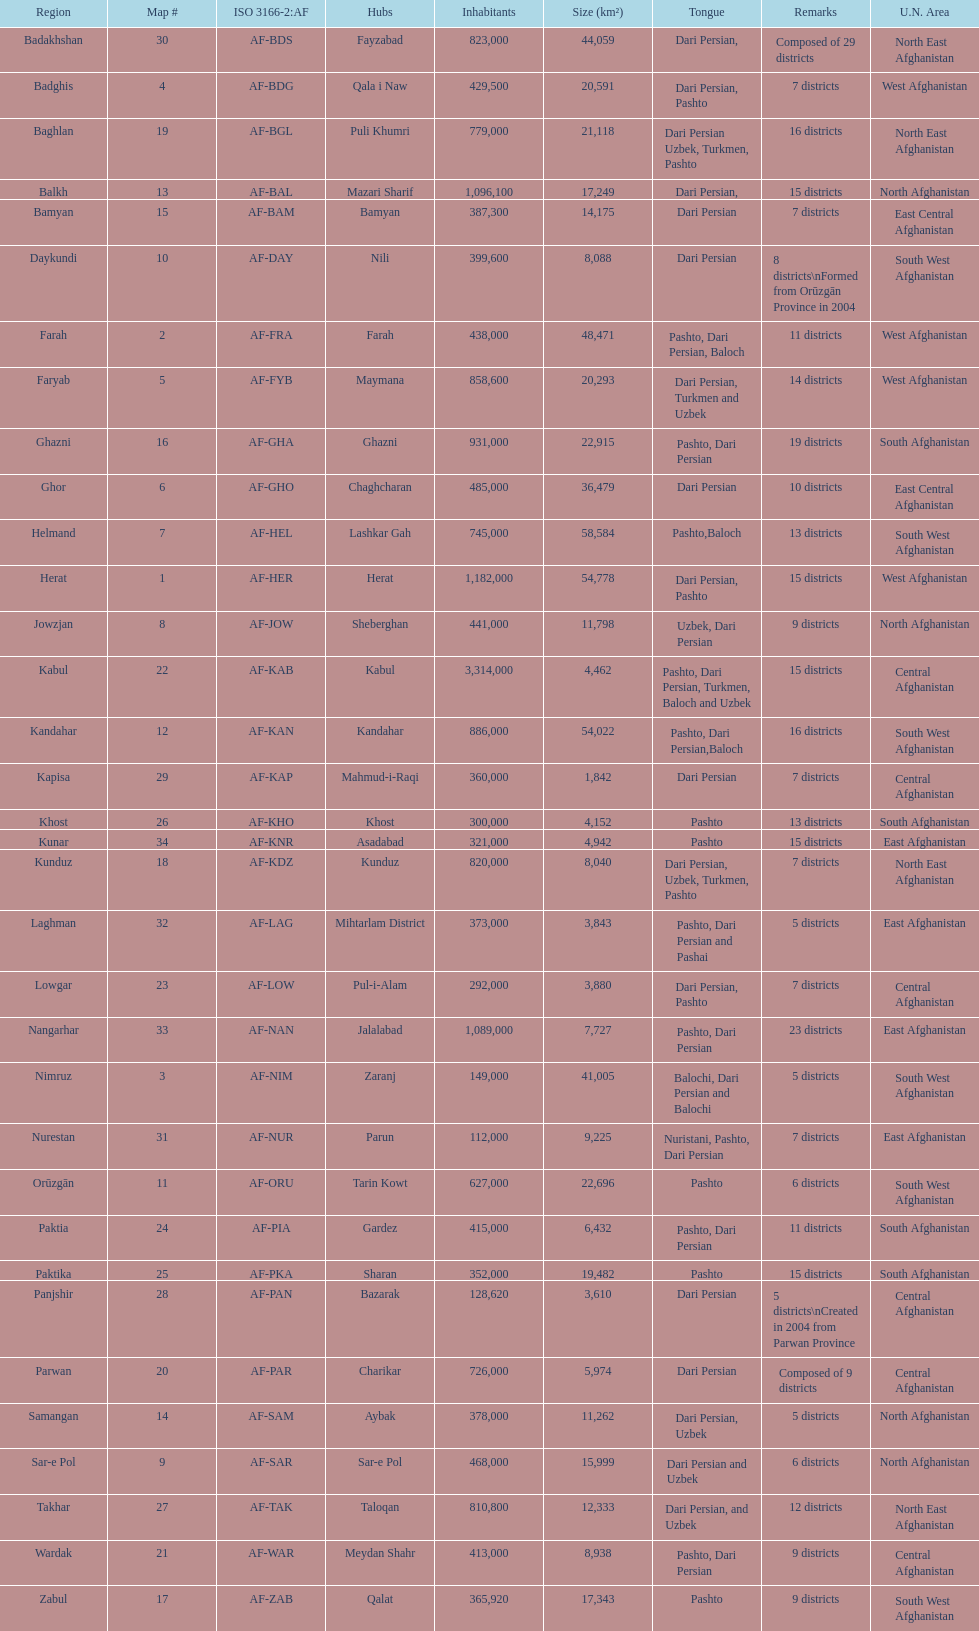What province is listed previous to ghor? Ghazni. 